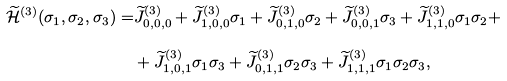<formula> <loc_0><loc_0><loc_500><loc_500>\widetilde { \mathcal { H } } ^ { ( 3 ) } ( \sigma _ { 1 } , \sigma _ { 2 } , \sigma _ { 3 } ) = & \widetilde { J } _ { 0 , 0 , 0 } ^ { ( 3 ) } + \widetilde { J } _ { 1 , 0 , 0 } ^ { ( 3 ) } \sigma _ { 1 } + \widetilde { J } _ { 0 , 1 , 0 } ^ { ( 3 ) } \sigma _ { 2 } + \widetilde { J } _ { 0 , 0 , 1 } ^ { ( 3 ) } \sigma _ { 3 } + \widetilde { J } _ { 1 , 1 , 0 } ^ { ( 3 ) } \sigma _ { 1 } \sigma _ { 2 } + \\ & + \widetilde { J } _ { 1 , 0 , 1 } ^ { ( 3 ) } \sigma _ { 1 } \sigma _ { 3 } + \widetilde { J } _ { 0 , 1 , 1 } ^ { ( 3 ) } \sigma _ { 2 } \sigma _ { 3 } + \widetilde { J } _ { 1 , 1 , 1 } ^ { ( 3 ) } \sigma _ { 1 } \sigma _ { 2 } \sigma _ { 3 } ,</formula> 